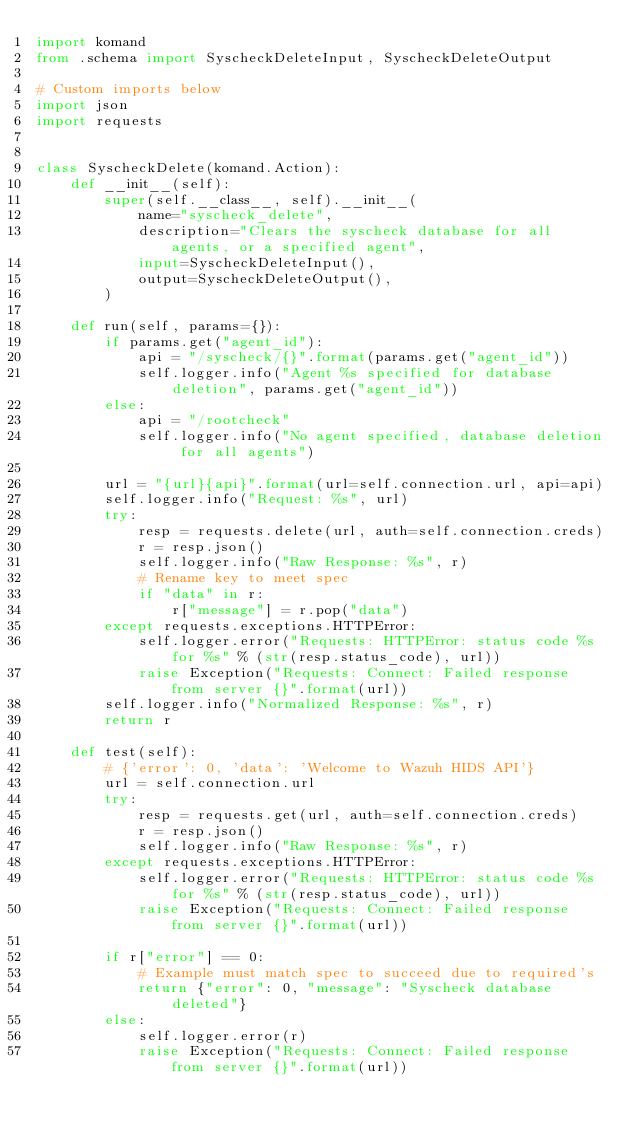<code> <loc_0><loc_0><loc_500><loc_500><_Python_>import komand
from .schema import SyscheckDeleteInput, SyscheckDeleteOutput

# Custom imports below
import json
import requests


class SyscheckDelete(komand.Action):
    def __init__(self):
        super(self.__class__, self).__init__(
            name="syscheck_delete",
            description="Clears the syscheck database for all agents, or a specified agent",
            input=SyscheckDeleteInput(),
            output=SyscheckDeleteOutput(),
        )

    def run(self, params={}):
        if params.get("agent_id"):
            api = "/syscheck/{}".format(params.get("agent_id"))
            self.logger.info("Agent %s specified for database deletion", params.get("agent_id"))
        else:
            api = "/rootcheck"
            self.logger.info("No agent specified, database deletion for all agents")

        url = "{url}{api}".format(url=self.connection.url, api=api)
        self.logger.info("Request: %s", url)
        try:
            resp = requests.delete(url, auth=self.connection.creds)
            r = resp.json()
            self.logger.info("Raw Response: %s", r)
            # Rename key to meet spec
            if "data" in r:
                r["message"] = r.pop("data")
        except requests.exceptions.HTTPError:
            self.logger.error("Requests: HTTPError: status code %s for %s" % (str(resp.status_code), url))
            raise Exception("Requests: Connect: Failed response from server {}".format(url))
        self.logger.info("Normalized Response: %s", r)
        return r

    def test(self):
        # {'error': 0, 'data': 'Welcome to Wazuh HIDS API'}
        url = self.connection.url
        try:
            resp = requests.get(url, auth=self.connection.creds)
            r = resp.json()
            self.logger.info("Raw Response: %s", r)
        except requests.exceptions.HTTPError:
            self.logger.error("Requests: HTTPError: status code %s for %s" % (str(resp.status_code), url))
            raise Exception("Requests: Connect: Failed response from server {}".format(url))

        if r["error"] == 0:
            # Example must match spec to succeed due to required's
            return {"error": 0, "message": "Syscheck database deleted"}
        else:
            self.logger.error(r)
            raise Exception("Requests: Connect: Failed response from server {}".format(url))
</code> 